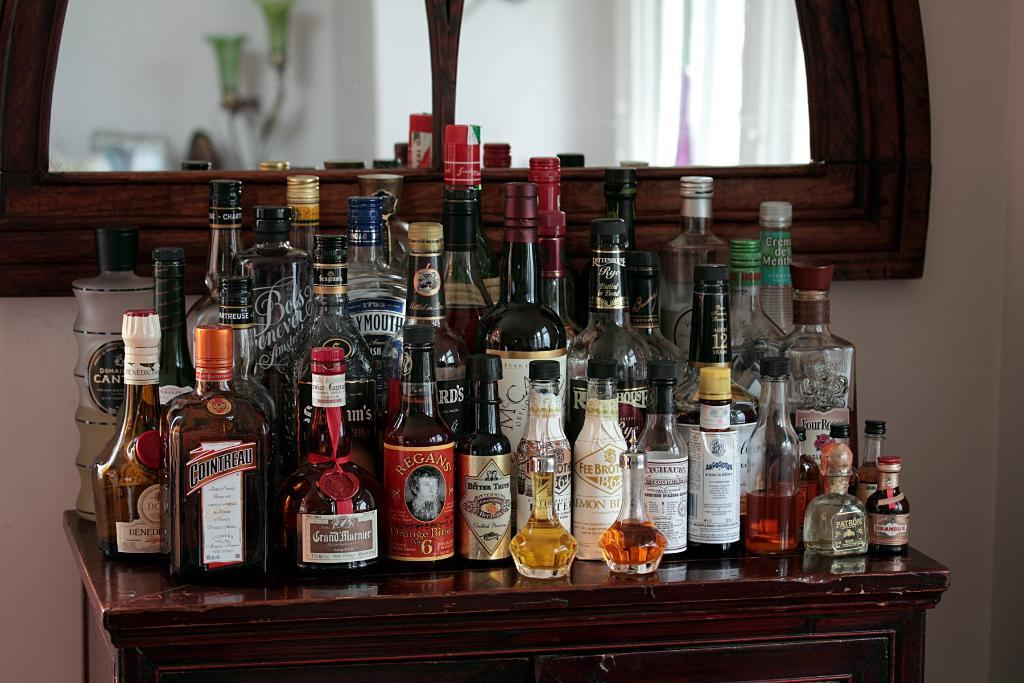<image>
Relay a brief, clear account of the picture shown. A large number of liquer bottles, one of which is Cointreau. 